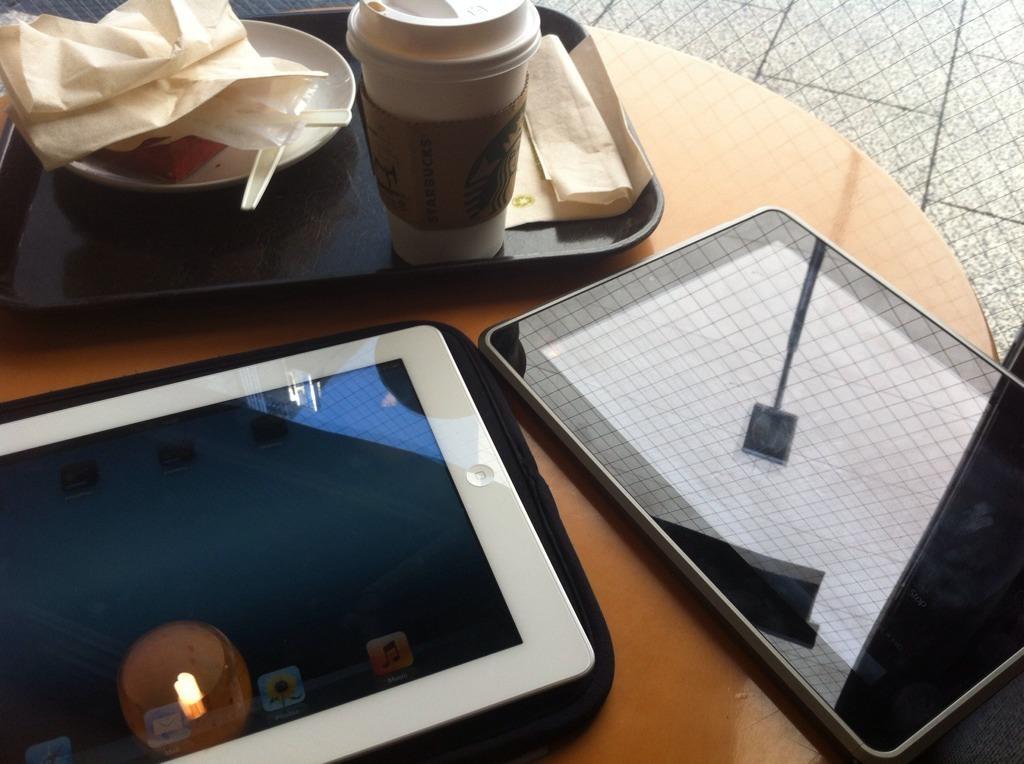How would you summarize this image in a sentence or two? In this image i can see two ipads,a tray, a glass,a plate,a paper on a table. 